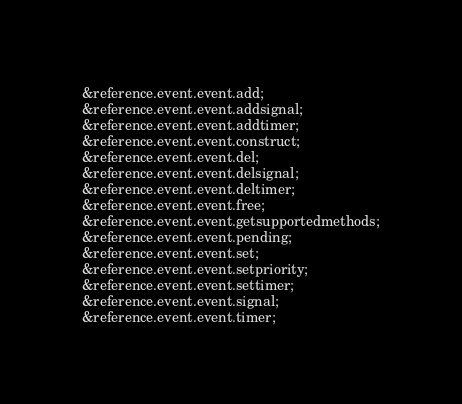Convert code to text. <code><loc_0><loc_0><loc_500><loc_500><_XML_>&reference.event.event.add;
&reference.event.event.addsignal;
&reference.event.event.addtimer;
&reference.event.event.construct;
&reference.event.event.del;
&reference.event.event.delsignal;
&reference.event.event.deltimer;
&reference.event.event.free;
&reference.event.event.getsupportedmethods;
&reference.event.event.pending;
&reference.event.event.set;
&reference.event.event.setpriority;
&reference.event.event.settimer;
&reference.event.event.signal;
&reference.event.event.timer;
</code> 